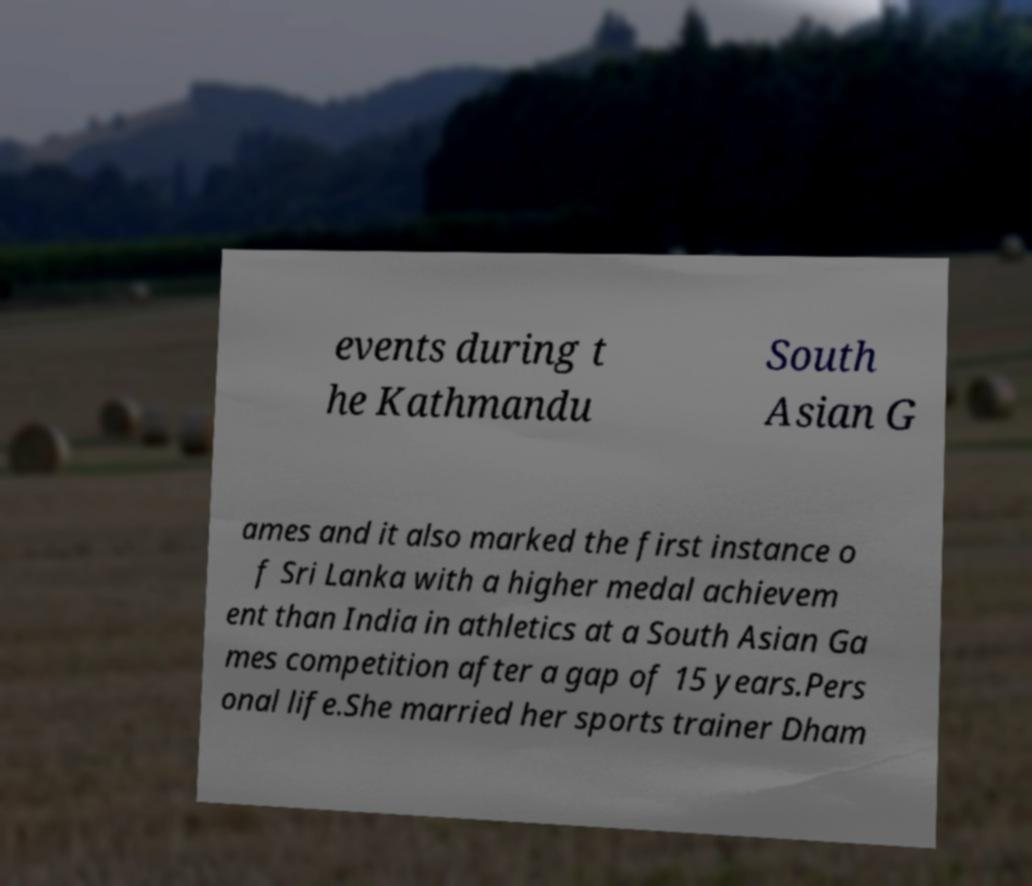What messages or text are displayed in this image? I need them in a readable, typed format. events during t he Kathmandu South Asian G ames and it also marked the first instance o f Sri Lanka with a higher medal achievem ent than India in athletics at a South Asian Ga mes competition after a gap of 15 years.Pers onal life.She married her sports trainer Dham 